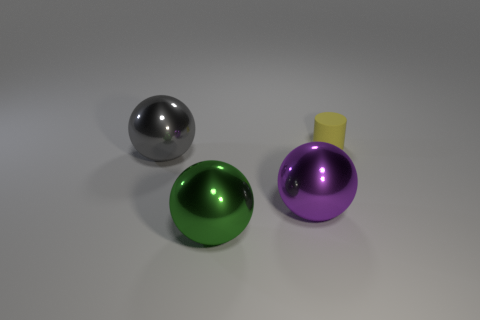Could you describe the material qualities indicated by the surfaces of the objects? Sure, the objects display glossy surfaces which suggest they are made of polished metal or a material with similar light-reflective characteristics, giving them a sleek and smooth appearance. 
Are there any imperfections visible on the objects? Upon closer examination, the objects appear to be flawless with no visible scratches or blemishes, signifying either newness or well-maintained conditions. 